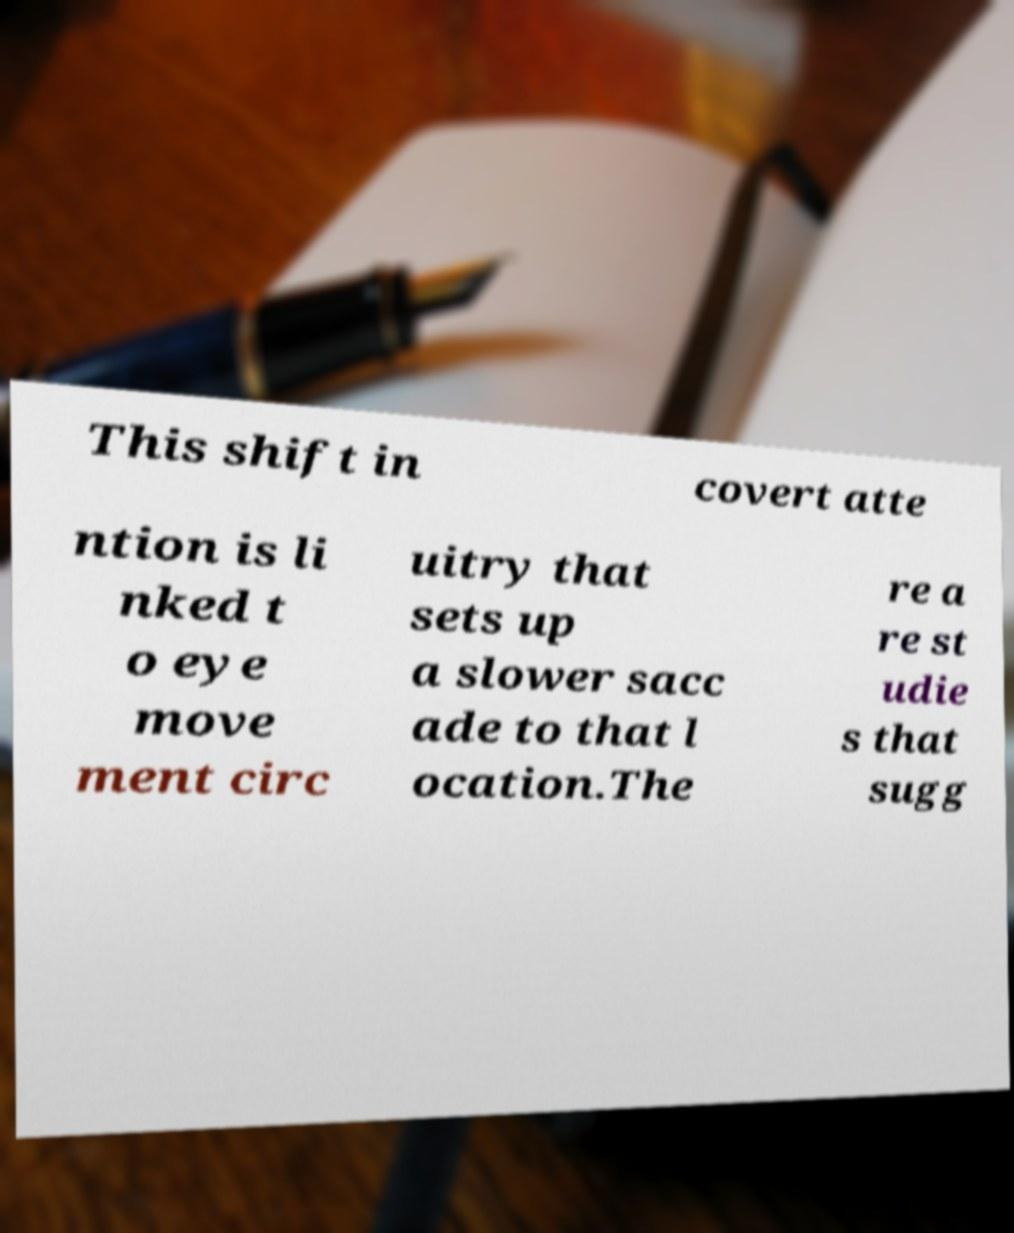Please identify and transcribe the text found in this image. This shift in covert atte ntion is li nked t o eye move ment circ uitry that sets up a slower sacc ade to that l ocation.The re a re st udie s that sugg 